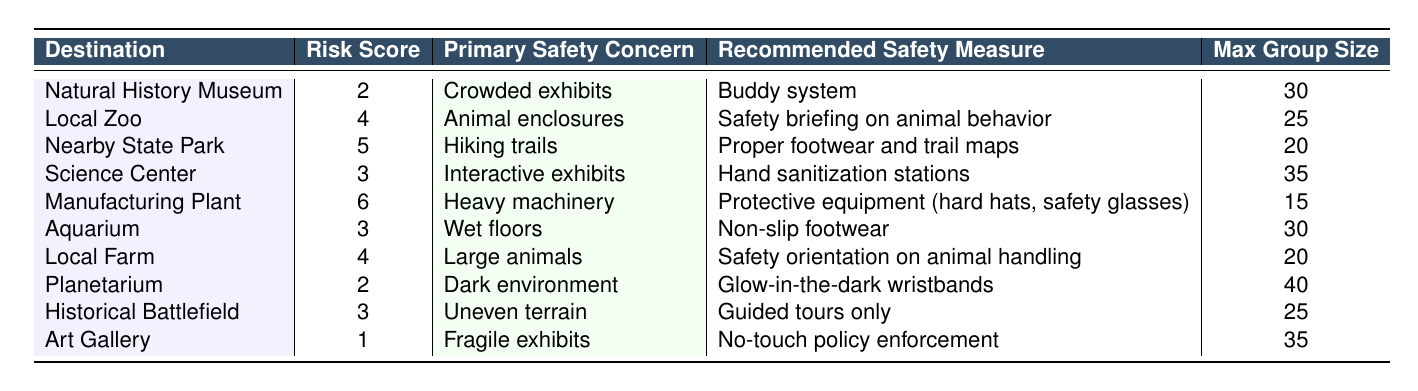What is the maximum group size allowed at the Aquarium? The table lists the maximum group size for the Aquarium as 30.
Answer: 30 What is the primary safety concern at the Local Zoo? According to the table, the primary safety concern at the Local Zoo is "Animal enclosures."
Answer: Animal enclosures Which destination has the highest risk score? The Manufacturing Plant has the highest risk score of 6 compared to the other destinations in the table.
Answer: Manufacturing Plant What safety measure is recommended for the Nearby State Park? The recommended safety measure for the Nearby State Park is "Proper footwear and trail maps," as indicated in the table.
Answer: Proper footwear and trail maps Is the Art Gallery's risk score lower than that of the Planetarium? Yes, the Art Gallery has a risk score of 1, while the Planetarium has a score of 2, making the Art Gallery's score lower.
Answer: Yes What is the average risk score for all destinations listed? The risk scores are 2, 4, 5, 3, 6, 3, 4, 2, 3, and 1. Summing them gives 33, and dividing by 10 (the number of destinations) results in an average risk score of 3.3.
Answer: 3.3 Which safety measure is common for the Local Farm and the Nearby State Park? Both locations recommend safety orientations related to handling animals and proper footwear, respectively. Thus, the common theme is ensuring participant safety in outdoor or animal-related environments.
Answer: N/A How many destinations have a risk score of 3 or below? There are four destinations (Natural History Museum, Science Center, Aquarium, and Art Gallery) with a risk score of 3 or below.
Answer: 4 Is the recommended safety measure for the Manufacturing Plant focused on personal protective equipment? Yes, the recommended safety measure for the Manufacturing Plant involves using protective equipment such as hard hats and safety glasses.
Answer: Yes If the maximum group size is 25, which destinations fall within that limit? The destinations that fall within a maximum group size of 25 are the Local Zoo, Nearby State Park, Manufacturing Plant, and Local Farm.
Answer: 4 